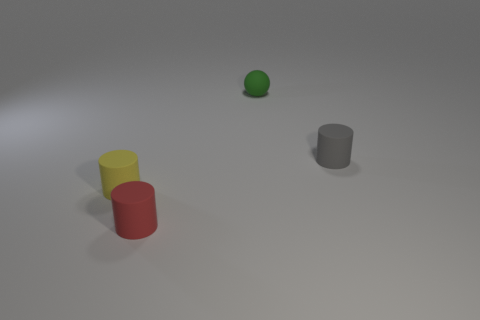Add 2 spheres. How many objects exist? 6 Subtract all gray matte cylinders. How many cylinders are left? 2 Subtract all red cylinders. How many cylinders are left? 2 Subtract 1 balls. How many balls are left? 0 Subtract all cyan spheres. Subtract all gray cubes. How many spheres are left? 1 Subtract all yellow blocks. How many purple balls are left? 0 Subtract all tiny purple things. Subtract all gray matte things. How many objects are left? 3 Add 4 tiny green rubber objects. How many tiny green rubber objects are left? 5 Add 4 tiny green balls. How many tiny green balls exist? 5 Subtract 0 yellow spheres. How many objects are left? 4 